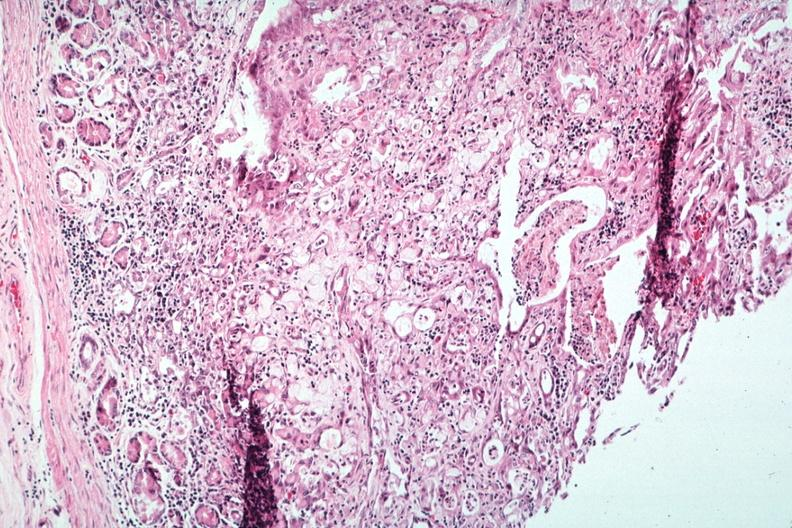s metastatic carcinoma present?
Answer the question using a single word or phrase. Yes 